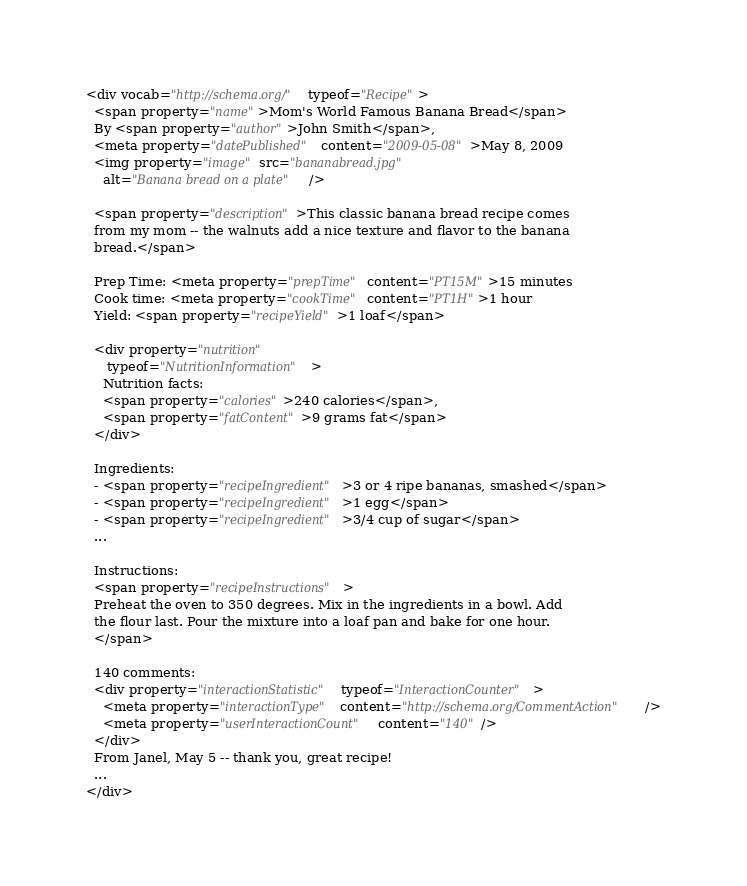<code> <loc_0><loc_0><loc_500><loc_500><_HTML_><div vocab="http://schema.org/" typeof="Recipe">
  <span property="name">Mom's World Famous Banana Bread</span>
  By <span property="author">John Smith</span>,
  <meta property="datePublished" content="2009-05-08">May 8, 2009
  <img property="image" src="bananabread.jpg"
    alt="Banana bread on a plate" />

  <span property="description">This classic banana bread recipe comes
  from my mom -- the walnuts add a nice texture and flavor to the banana
  bread.</span>

  Prep Time: <meta property="prepTime" content="PT15M">15 minutes
  Cook time: <meta property="cookTime" content="PT1H">1 hour
  Yield: <span property="recipeYield">1 loaf</span>

  <div property="nutrition"
     typeof="NutritionInformation">
    Nutrition facts:
    <span property="calories">240 calories</span>,
    <span property="fatContent">9 grams fat</span>
  </div>

  Ingredients:
  - <span property="recipeIngredient">3 or 4 ripe bananas, smashed</span>
  - <span property="recipeIngredient">1 egg</span>
  - <span property="recipeIngredient">3/4 cup of sugar</span>
  ...

  Instructions:
  <span property="recipeInstructions">
  Preheat the oven to 350 degrees. Mix in the ingredients in a bowl. Add
  the flour last. Pour the mixture into a loaf pan and bake for one hour.
  </span>

  140 comments:
  <div property="interactionStatistic" typeof="InteractionCounter">
    <meta property="interactionType" content="http://schema.org/CommentAction" />
    <meta property="userInteractionCount" content="140" />
  </div>
  From Janel, May 5 -- thank you, great recipe!
  ...
</div>
</code> 